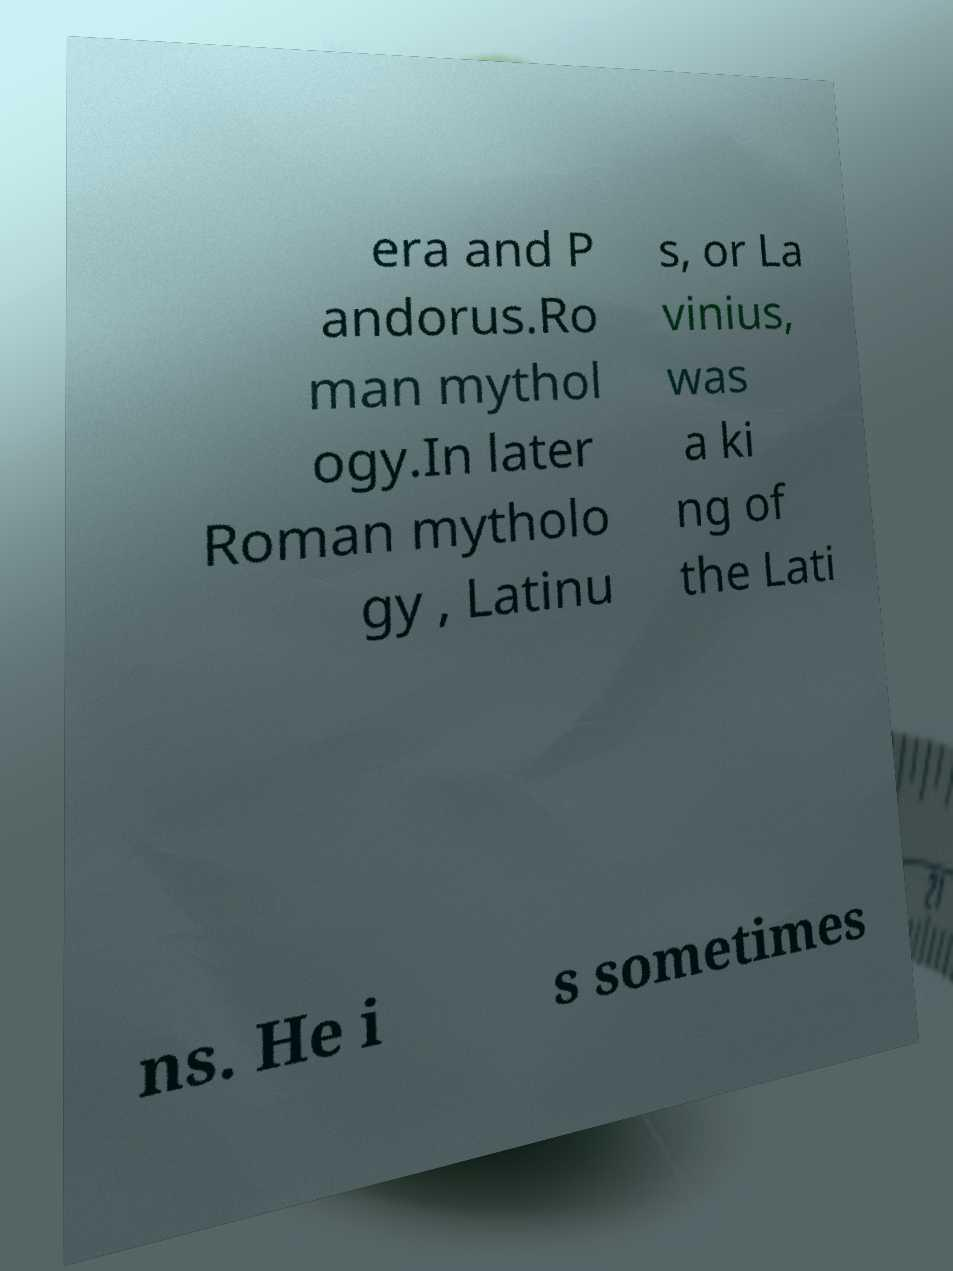What messages or text are displayed in this image? I need them in a readable, typed format. era and P andorus.Ro man mythol ogy.In later Roman mytholo gy , Latinu s, or La vinius, was a ki ng of the Lati ns. He i s sometimes 